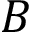Convert formula to latex. <formula><loc_0><loc_0><loc_500><loc_500>B</formula> 